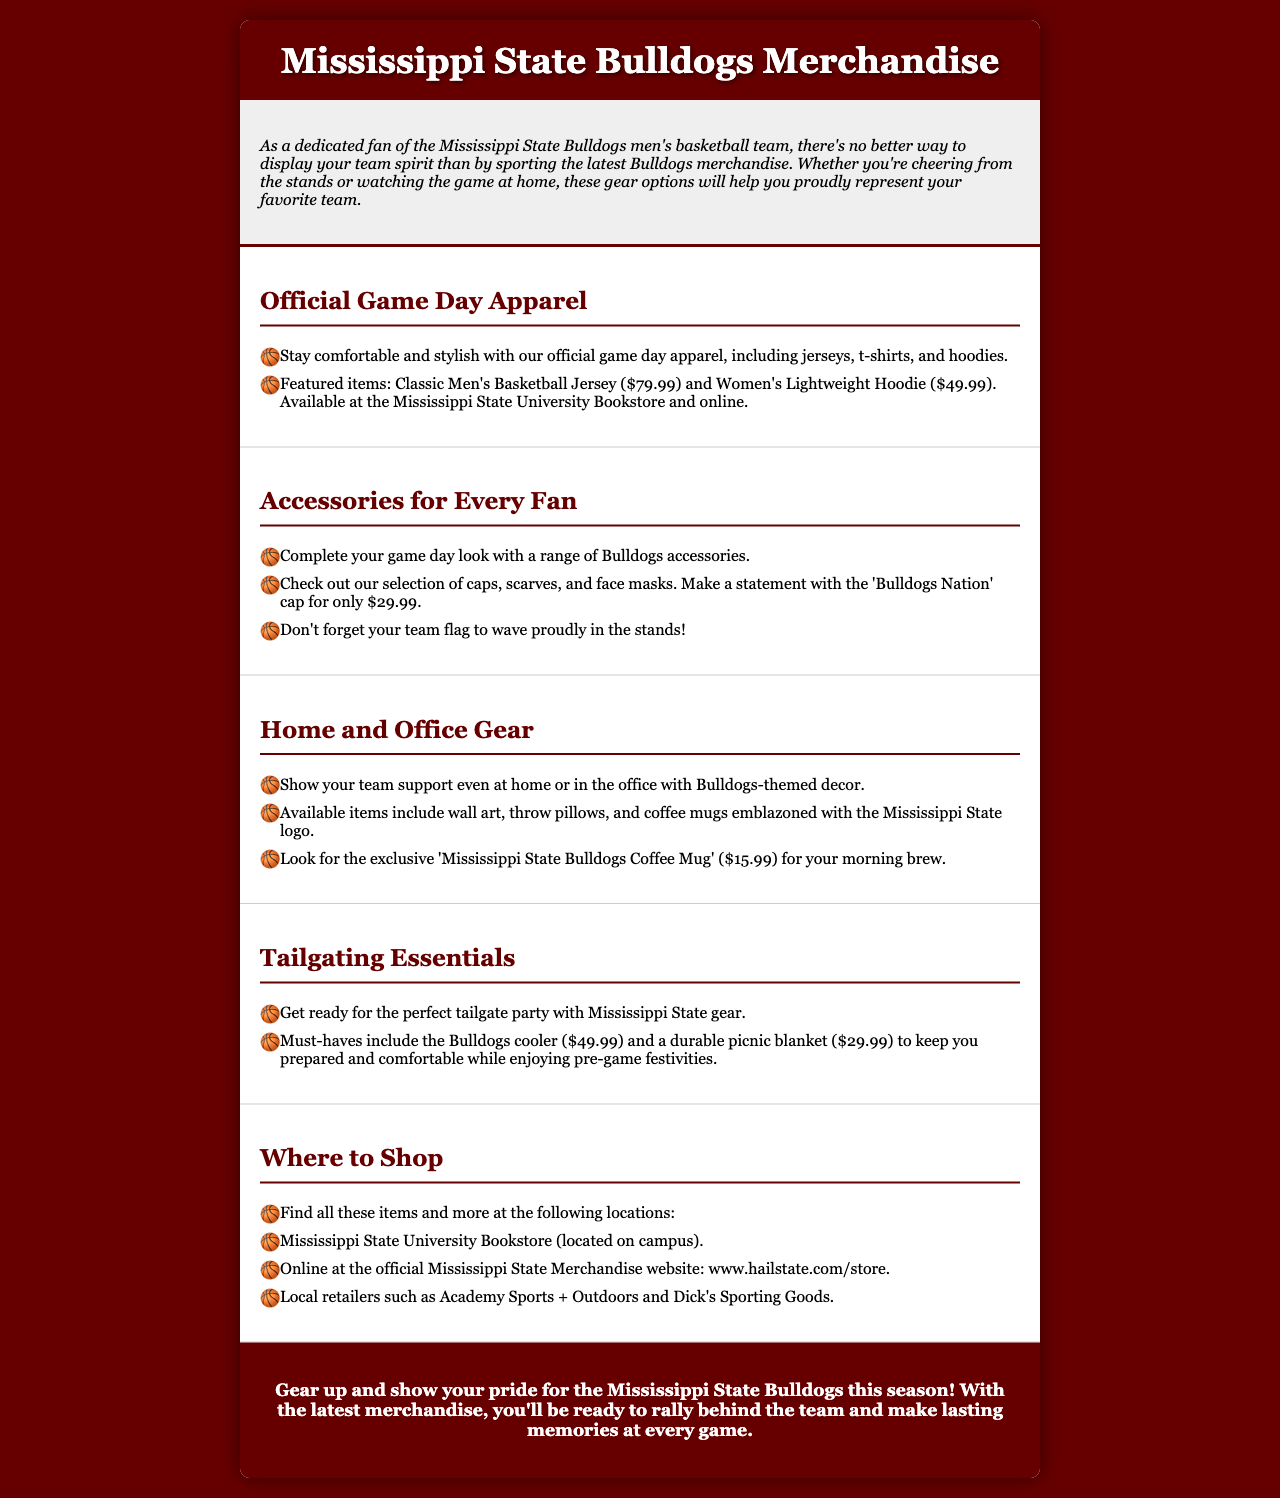What is the price of the Classic Men's Basketball Jersey? The price of the Classic Men's Basketball Jersey is mentioned in the apparel section of the document.
Answer: $79.99 Where can the Bulldogs cooler be purchased? The Bulldogs cooler is listed under the Tailgating Essentials section, and the document mentions locations to shop.
Answer: Mississippi State University Bookstore What type of apparel is mentioned for women? The apparel section includes specific mentions of clothing items for women.
Answer: Women's Lightweight Hoodie What is the price of the 'Mississippi State Bulldogs Coffee Mug'? The price of the coffee mug is stated in the Home and Office Gear section.
Answer: $15.99 Which cap is mentioned in the accessory list? The accessories section specifically mentions one type of cap.
Answer: 'Bulldogs Nation' cap What color is the background of the brochure? The background color is described in the style section of the document.
Answer: #660000 How many sections are present in the brochure? The sections mentioned in the document cover different categories of merchandise.
Answer: Five What statement is emphasized in the conclusion? The conclusion encourages fans to show their pride and memory-making at games.
Answer: Gear up and show your pride for the Mississippi State Bulldogs this season! 